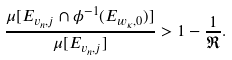Convert formula to latex. <formula><loc_0><loc_0><loc_500><loc_500>\frac { \mu [ E _ { v _ { n } , j } \cap \phi ^ { - 1 } ( E _ { w _ { \kappa } , 0 } ) ] } { \mu [ E _ { v _ { n } , j } ] } > 1 - \frac { 1 } { \mathfrak R } .</formula> 